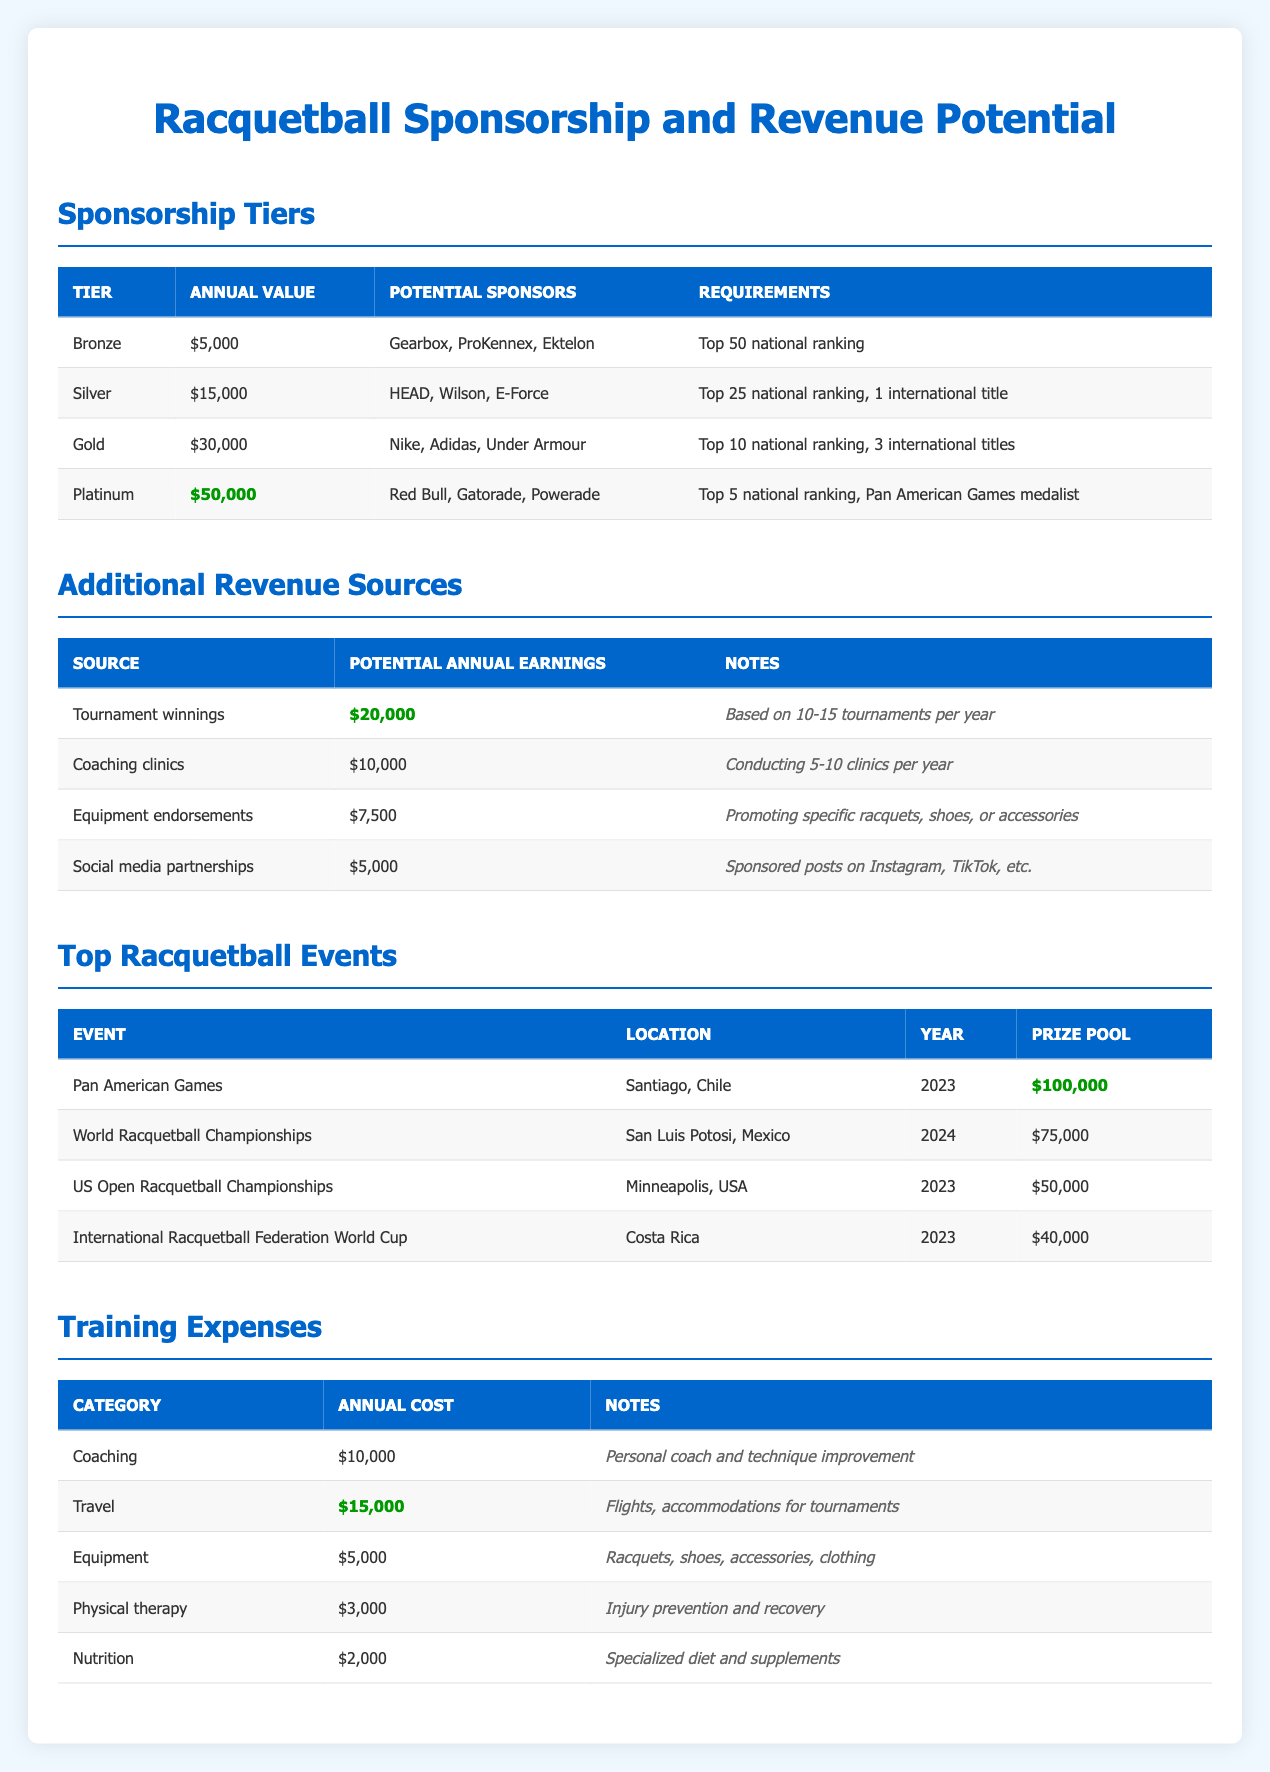What is the annual value of the Gold sponsorship tier? The annual value for the Gold sponsorship tier is clearly listed in the table. Under the "Annual Value" column for the Gold tier, it states "$30,000".
Answer: 30,000 How many potential sponsors are listed for the Platinum tier? In the "Potential Sponsors" column for the Platinum tier, there are three sponsors mentioned: Red Bull, Gatorade, and Powerade. Thus, the total is counted as three.
Answer: 3 What is the total potential annual earnings from all additional revenue sources? The potential annual earnings from the additional sources are: Tournament winnings ($20,000) + Coaching clinics ($10,000) + Equipment endorsements ($7,500) + Social media partnerships ($5,000). Adding these together gives $20,000 + $10,000 + $7,500 + $5,000 = $42,500.
Answer: 42,500 Is a Pan American Games medalist required for the Silver sponsorship tier? The Silver tier requirements include a "Top 25 national ranking" and "1 international title," but does not mention being a Pan American Games medalist. Thus, this statement is false.
Answer: No If someone achieved a Top 5 national ranking and was a Pan American Games medalist, what is the total annual revenue they could expect from the Platinum tier and additional revenue sources? For the Platinum tier, the annual value is $50,000. Based on additional revenue sources, the potential earnings are $42,500. Adding them gives $50,000 + $42,500 = $92,500.
Answer: 92,500 What are the training expenses for equipment? The training expenses for equipment are clearly stated in the last table under the "Annual Cost" column, which shows an amount of $5,000.
Answer: 5,000 Is the prize pool for the US Open Racquetball Championships higher than the International Racquetball Federation World Cup? The prize pool for the US Open Racquetball Championships is $50,000 while the prize pool for the International Racquetball Federation World Cup is $40,000. Since $50,000 is greater than $40,000, this statement is true.
Answer: Yes What is the combined cost of travel and coaching in annual expenses? The annual costs listed are: Travel ($15,000) + Coaching ($10,000). Adding these amounts gives $15,000 + $10,000 = $25,000.
Answer: 25,000 